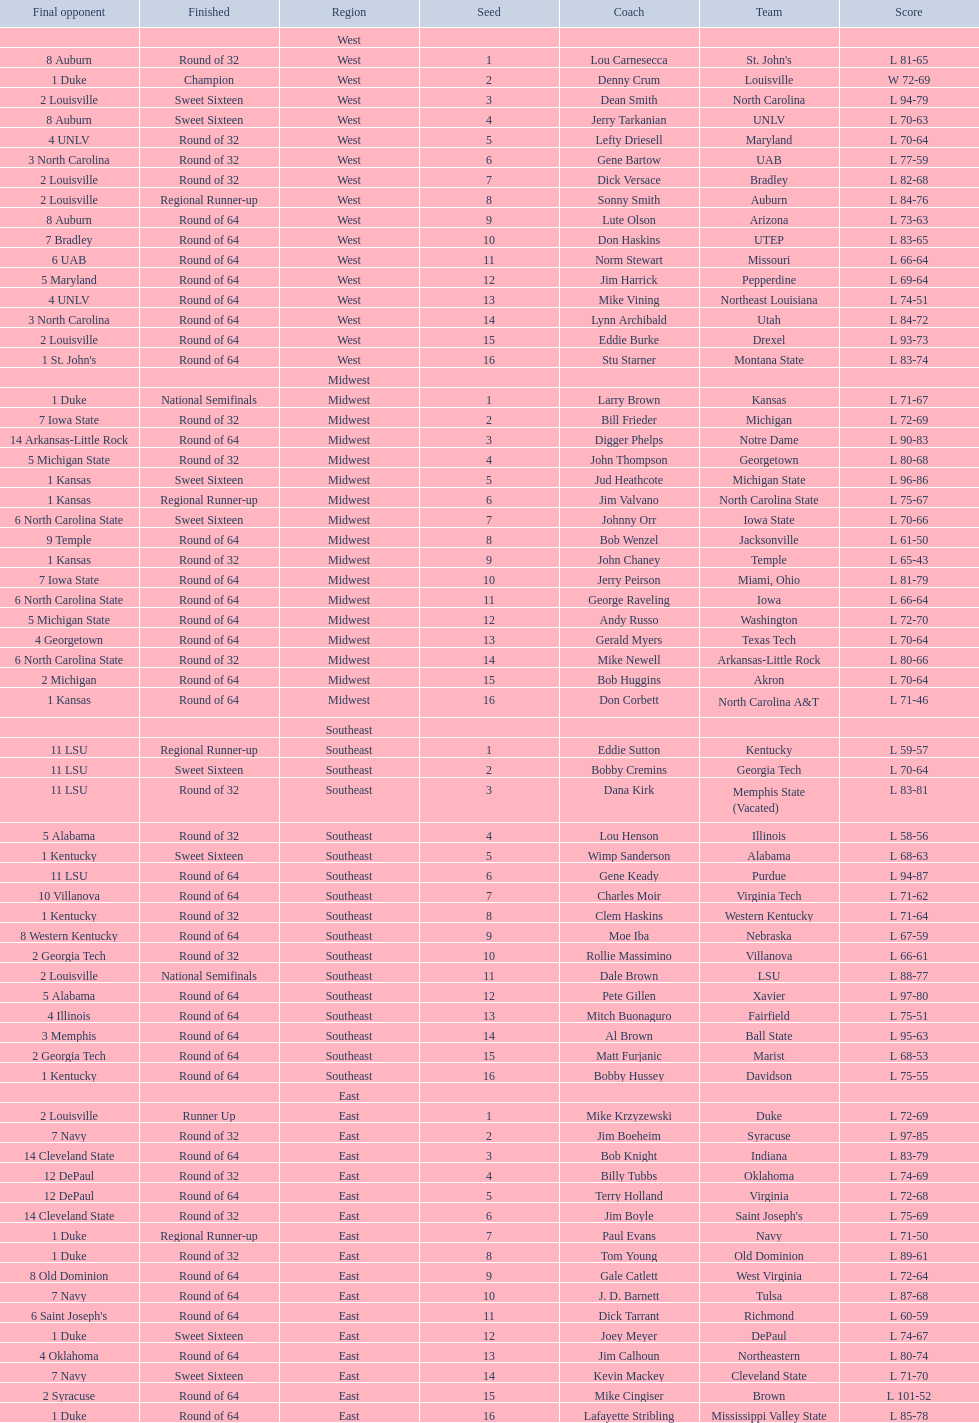North carolina and unlv each made it to which round? Sweet Sixteen. 